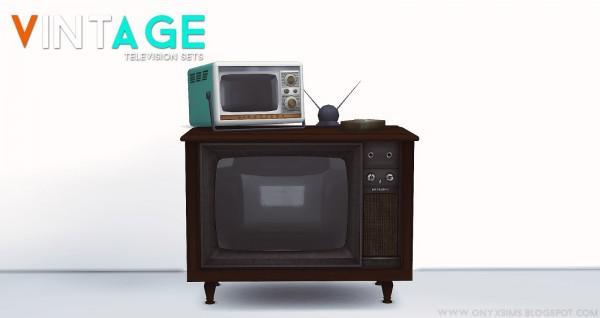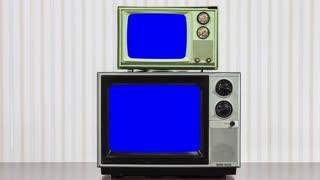The first image is the image on the left, the second image is the image on the right. Considering the images on both sides, is "Two televisions touch each other in at least one of the images." valid? Answer yes or no. Yes. The first image is the image on the left, the second image is the image on the right. Given the left and right images, does the statement "An image shows a smaller dark-screened TV with a bigger dark-screened TV, and both are sitting on some type of surface." hold true? Answer yes or no. Yes. 